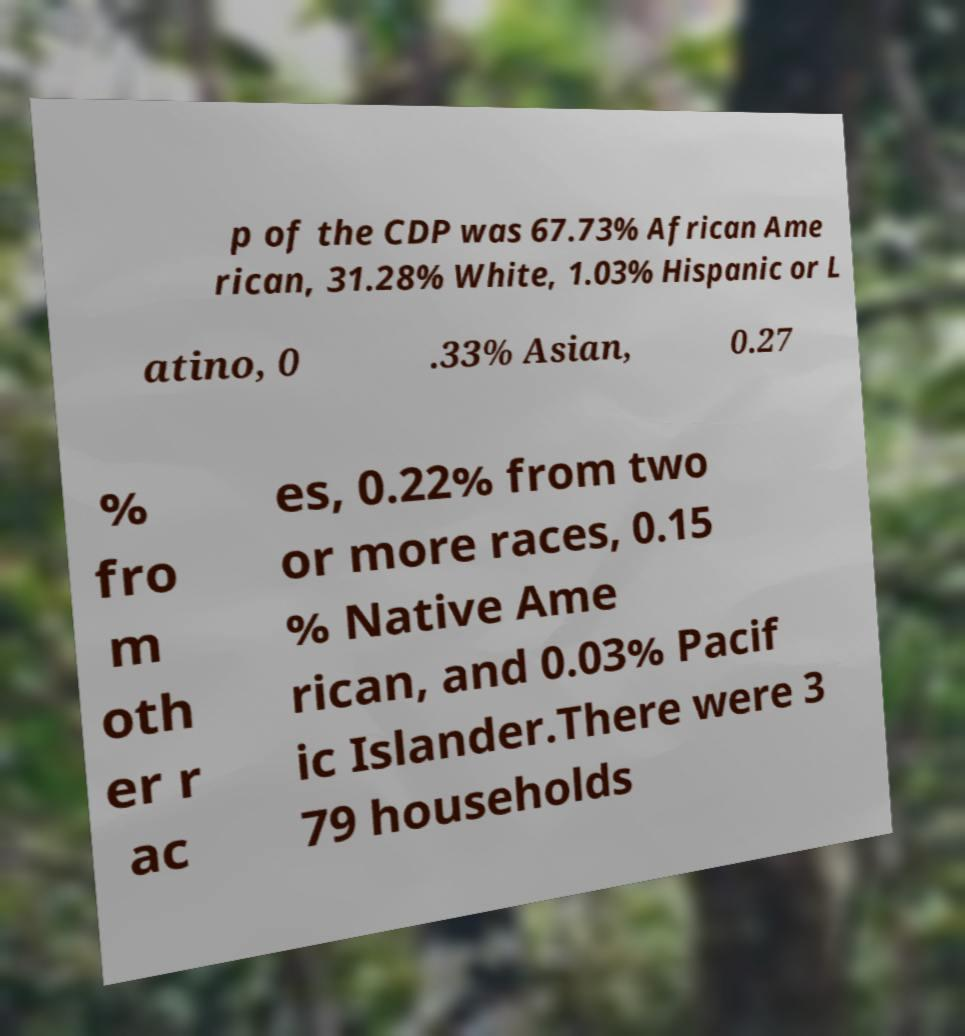What messages or text are displayed in this image? I need them in a readable, typed format. p of the CDP was 67.73% African Ame rican, 31.28% White, 1.03% Hispanic or L atino, 0 .33% Asian, 0.27 % fro m oth er r ac es, 0.22% from two or more races, 0.15 % Native Ame rican, and 0.03% Pacif ic Islander.There were 3 79 households 